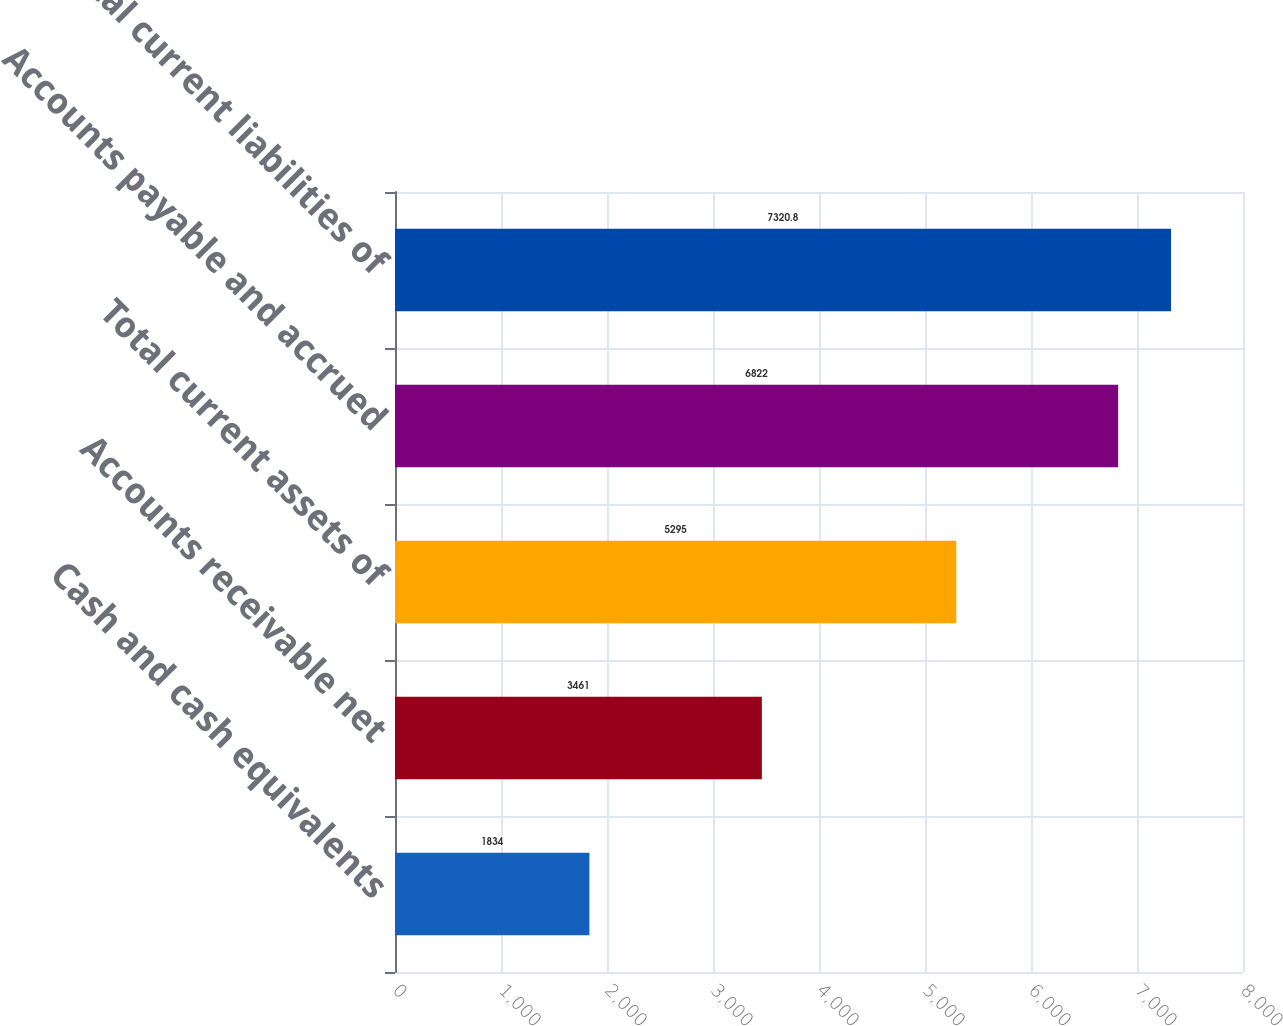Convert chart to OTSL. <chart><loc_0><loc_0><loc_500><loc_500><bar_chart><fcel>Cash and cash equivalents<fcel>Accounts receivable net<fcel>Total current assets of<fcel>Accounts payable and accrued<fcel>Total current liabilities of<nl><fcel>1834<fcel>3461<fcel>5295<fcel>6822<fcel>7320.8<nl></chart> 